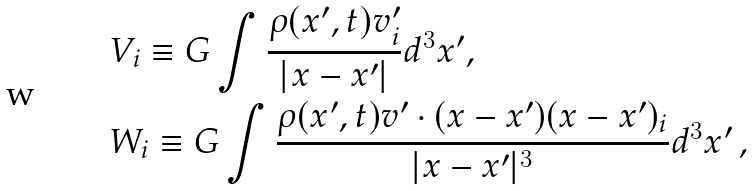Convert formula to latex. <formula><loc_0><loc_0><loc_500><loc_500>& V _ { i } \equiv G \int \frac { \rho ( x ^ { \prime } , t ) v ^ { \prime } _ { i } } { | x - x ^ { \prime } | } d ^ { 3 } x ^ { \prime } , \\ & W _ { i } \equiv G \int \frac { \rho ( x ^ { \prime } , t ) v ^ { \prime } \cdot ( x - x ^ { \prime } ) ( x - x ^ { \prime } ) _ { i } } { | x - x ^ { \prime } | ^ { 3 } } d ^ { 3 } x ^ { \prime } \, ,</formula> 